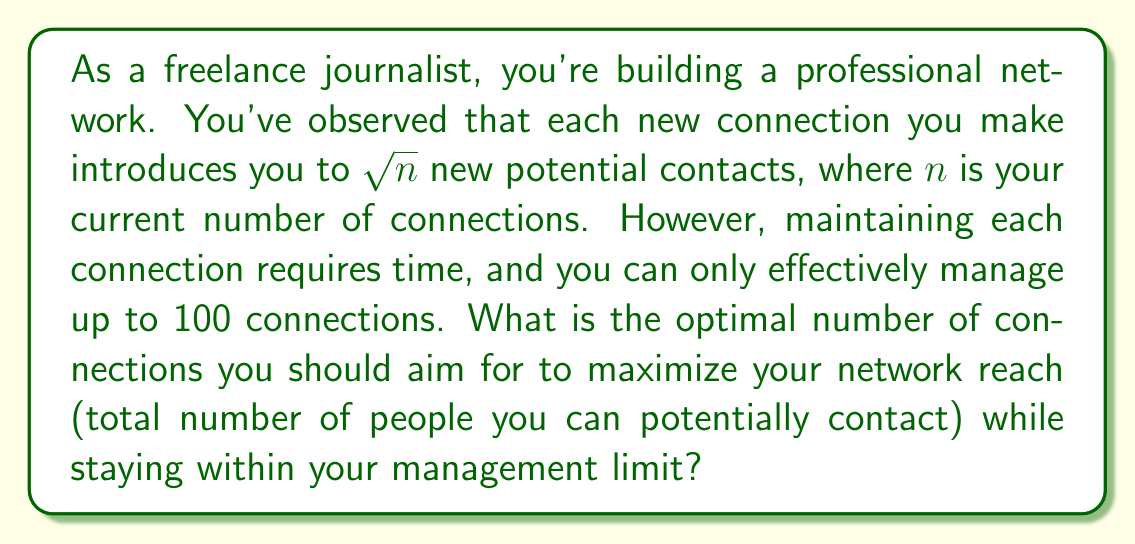What is the answer to this math problem? Let's approach this step-by-step:

1) Let $x$ be the number of direct connections you have.

2) Each of these $x$ connections introduces you to $\sqrt{x}$ new potential contacts.

3) So, the total network reach $R(x)$ is:
   $$R(x) = x + x\sqrt{x} = x(1 + \sqrt{x})$$

4) We need to maximize this function subject to the constraint $x \leq 100$.

5) To find the maximum, we can differentiate $R(x)$ with respect to $x$:
   $$\frac{dR}{dx} = 1 + \sqrt{x} + x \cdot \frac{1}{2\sqrt{x}} = 1 + \sqrt{x} + \frac{\sqrt{x}}{2} = 1 + \frac{3\sqrt{x}}{2}$$

6) Setting this equal to zero:
   $$1 + \frac{3\sqrt{x}}{2} = 0$$
   $$\frac{3\sqrt{x}}{2} = -1$$
   $$\sqrt{x} = -\frac{2}{3}$$

7) This gives us a negative value for $x$, which is not possible in our context. This means the function is always increasing within our domain.

8) Given that the function is always increasing and we have an upper limit of 100 connections, the optimal number of connections is 100.

9) We can verify this by calculating the network reach for 100 connections:
   $$R(100) = 100(1 + \sqrt{100}) = 100(1 + 10) = 1100$$

This means with 100 direct connections, you can potentially reach 1100 people in total.
Answer: The optimal number of connections is 100, which provides a maximum network reach of 1100 people. 